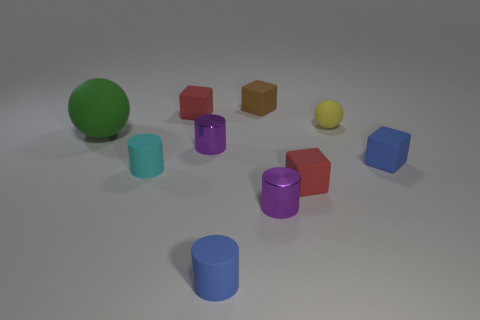How many rubber objects are tiny cyan objects or cubes?
Your response must be concise. 5. How many large objects are there?
Offer a terse response. 1. The matte sphere that is the same size as the cyan rubber cylinder is what color?
Offer a very short reply. Yellow. Do the yellow ball and the green rubber object have the same size?
Your answer should be very brief. No. There is a cyan object; is it the same size as the ball left of the small brown matte object?
Ensure brevity in your answer.  No. The matte block that is both to the right of the blue matte cylinder and behind the large green thing is what color?
Give a very brief answer. Brown. Are there more matte blocks that are left of the tiny ball than blue things that are behind the blue rubber cylinder?
Your response must be concise. Yes. There is a brown block that is made of the same material as the tiny yellow sphere; what is its size?
Provide a short and direct response. Small. There is a blue matte object that is to the left of the small brown matte block; how many tiny brown rubber objects are behind it?
Give a very brief answer. 1. Is there another cyan object of the same shape as the big thing?
Offer a terse response. No. 